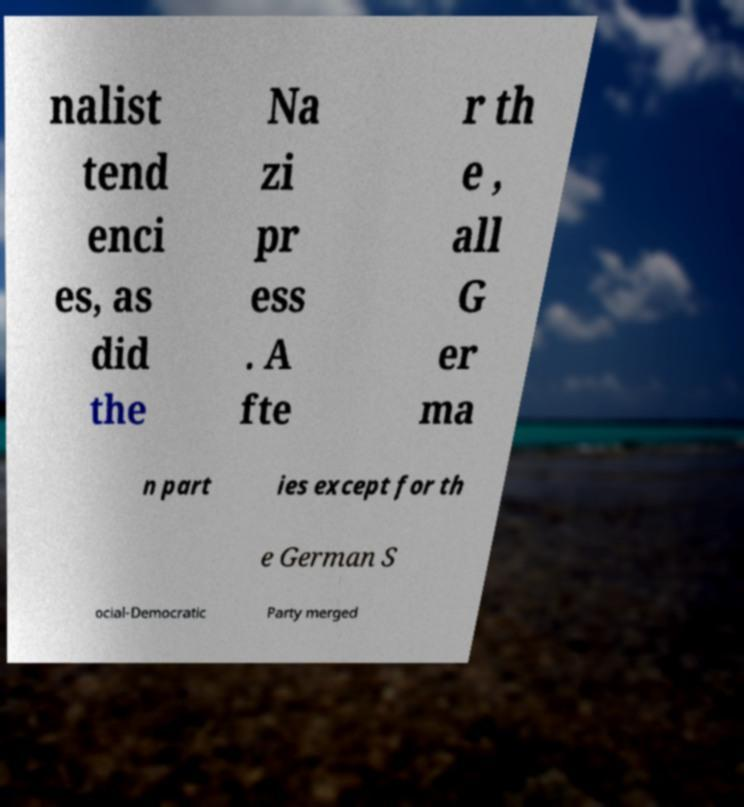Can you read and provide the text displayed in the image?This photo seems to have some interesting text. Can you extract and type it out for me? nalist tend enci es, as did the Na zi pr ess . A fte r th e , all G er ma n part ies except for th e German S ocial-Democratic Party merged 